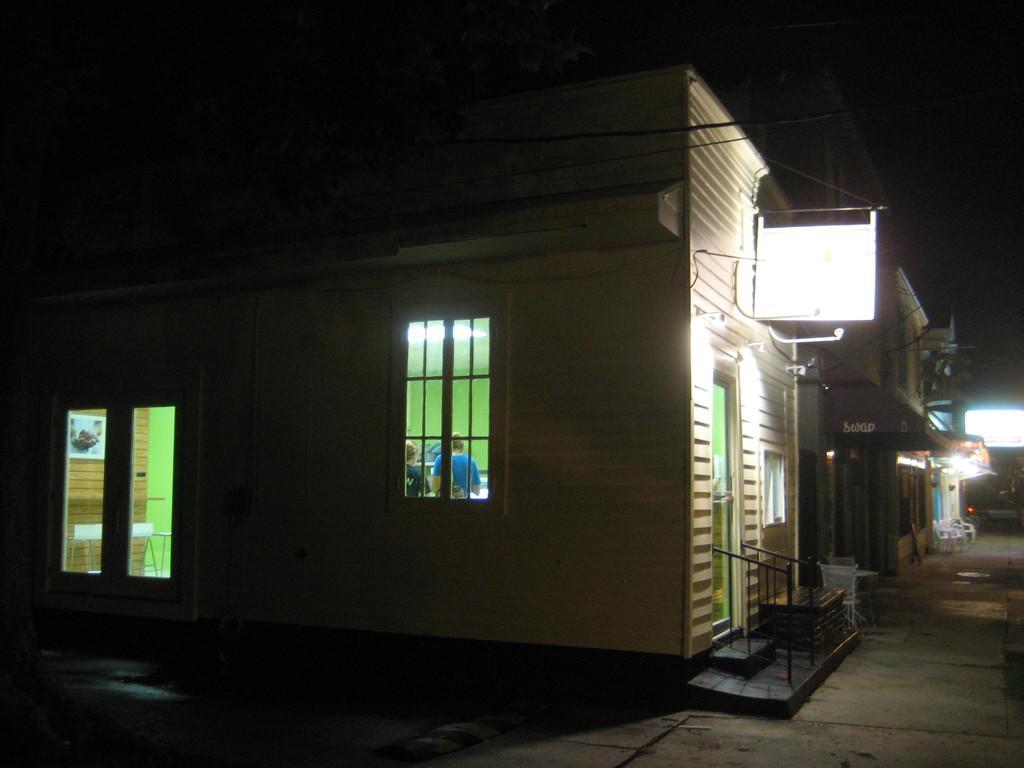Can you describe this image briefly? This picture contains a building and windows from which we can see two people standing and we even see a table and a green wall and a brown wall on which photo frame is placed. On the right side of the picture, we see a street light and the staircase. At the top of the picture, it is black in color and this picture is clicked in the dark. 